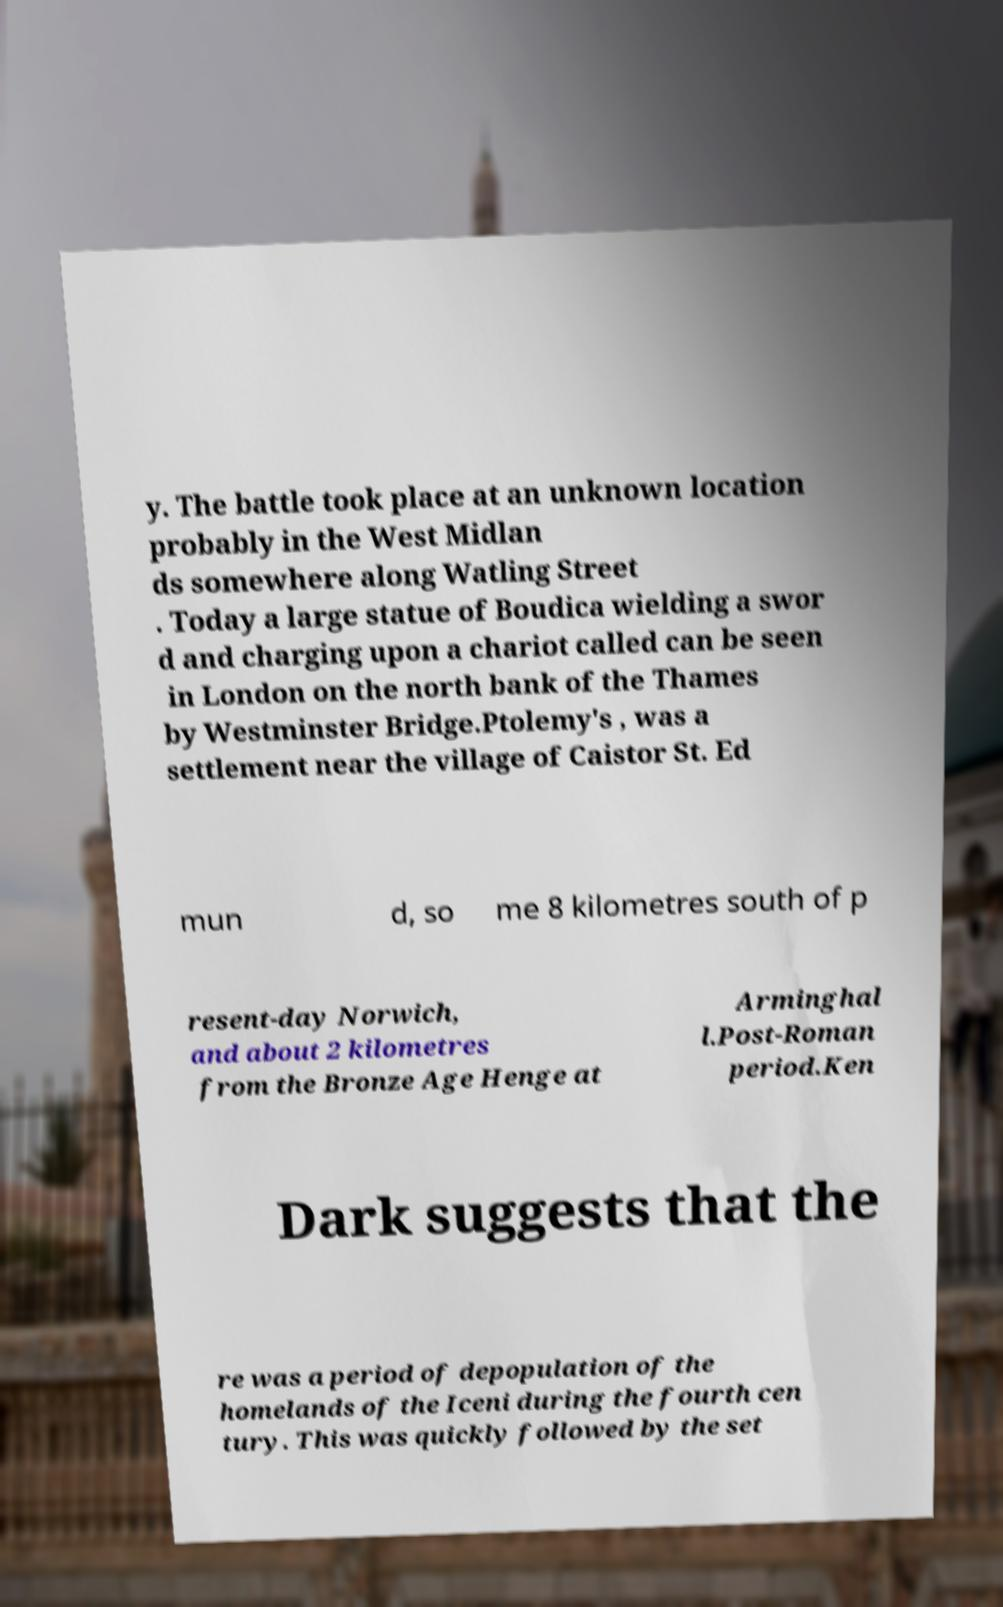There's text embedded in this image that I need extracted. Can you transcribe it verbatim? y. The battle took place at an unknown location probably in the West Midlan ds somewhere along Watling Street . Today a large statue of Boudica wielding a swor d and charging upon a chariot called can be seen in London on the north bank of the Thames by Westminster Bridge.Ptolemy's , was a settlement near the village of Caistor St. Ed mun d, so me 8 kilometres south of p resent-day Norwich, and about 2 kilometres from the Bronze Age Henge at Arminghal l.Post-Roman period.Ken Dark suggests that the re was a period of depopulation of the homelands of the Iceni during the fourth cen tury. This was quickly followed by the set 